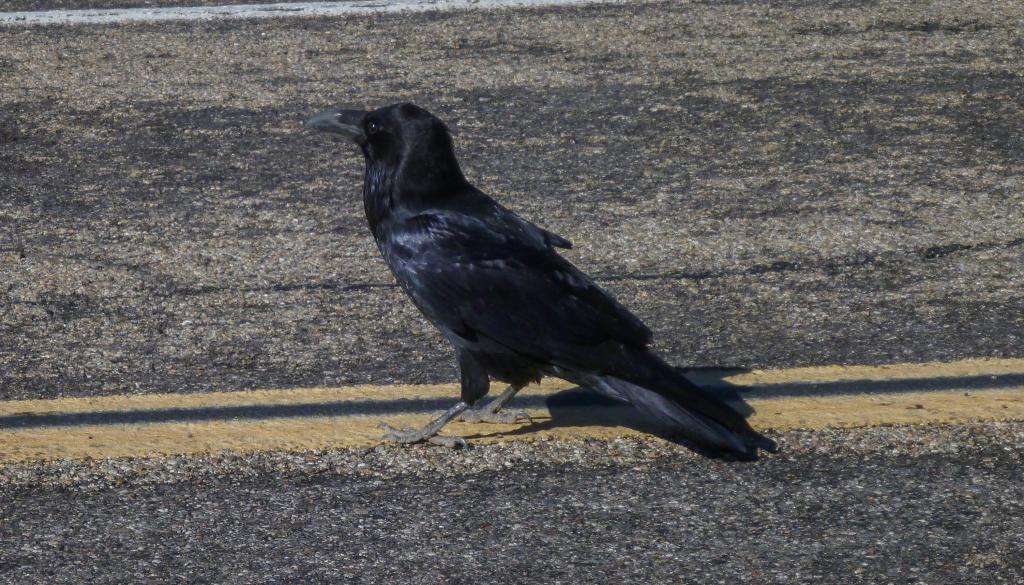What type of bird is in the image? There is a crow in the image. Where is the crow located in the image? The crow is standing on the road. What can be seen on the road in the image? There is a yellow line on the road. What type of wealth is the crow guarding in the image? There is no indication of wealth or any valuable items in the image; it simply features a crow standing on the road. What brand of toothpaste is the crow using in the image? There is no toothpaste or any reference to dental hygiene in the image; it only shows a crow standing on the road. 